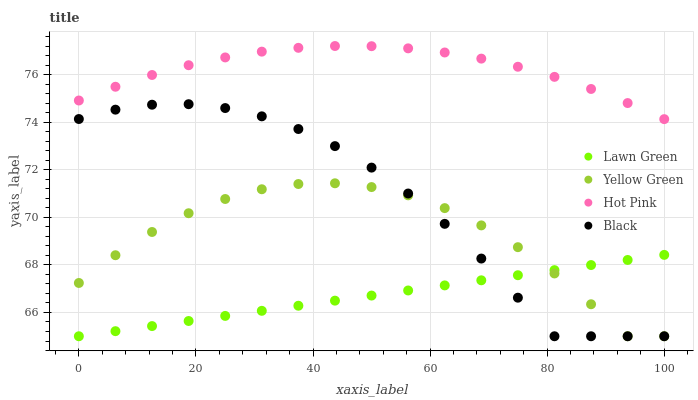Does Lawn Green have the minimum area under the curve?
Answer yes or no. Yes. Does Hot Pink have the maximum area under the curve?
Answer yes or no. Yes. Does Black have the minimum area under the curve?
Answer yes or no. No. Does Black have the maximum area under the curve?
Answer yes or no. No. Is Lawn Green the smoothest?
Answer yes or no. Yes. Is Yellow Green the roughest?
Answer yes or no. Yes. Is Hot Pink the smoothest?
Answer yes or no. No. Is Hot Pink the roughest?
Answer yes or no. No. Does Lawn Green have the lowest value?
Answer yes or no. Yes. Does Hot Pink have the lowest value?
Answer yes or no. No. Does Hot Pink have the highest value?
Answer yes or no. Yes. Does Black have the highest value?
Answer yes or no. No. Is Yellow Green less than Hot Pink?
Answer yes or no. Yes. Is Hot Pink greater than Black?
Answer yes or no. Yes. Does Lawn Green intersect Black?
Answer yes or no. Yes. Is Lawn Green less than Black?
Answer yes or no. No. Is Lawn Green greater than Black?
Answer yes or no. No. Does Yellow Green intersect Hot Pink?
Answer yes or no. No. 